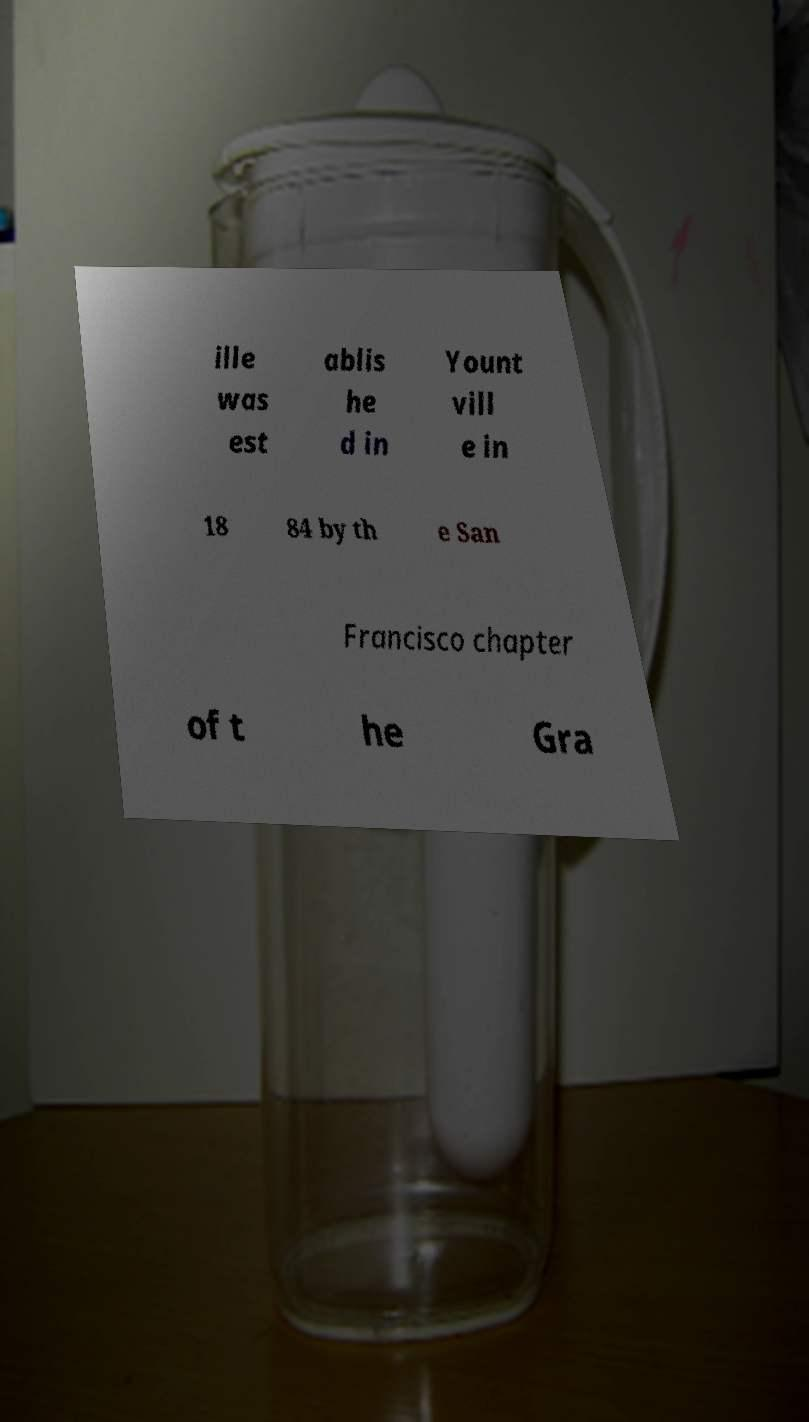Can you accurately transcribe the text from the provided image for me? ille was est ablis he d in Yount vill e in 18 84 by th e San Francisco chapter of t he Gra 